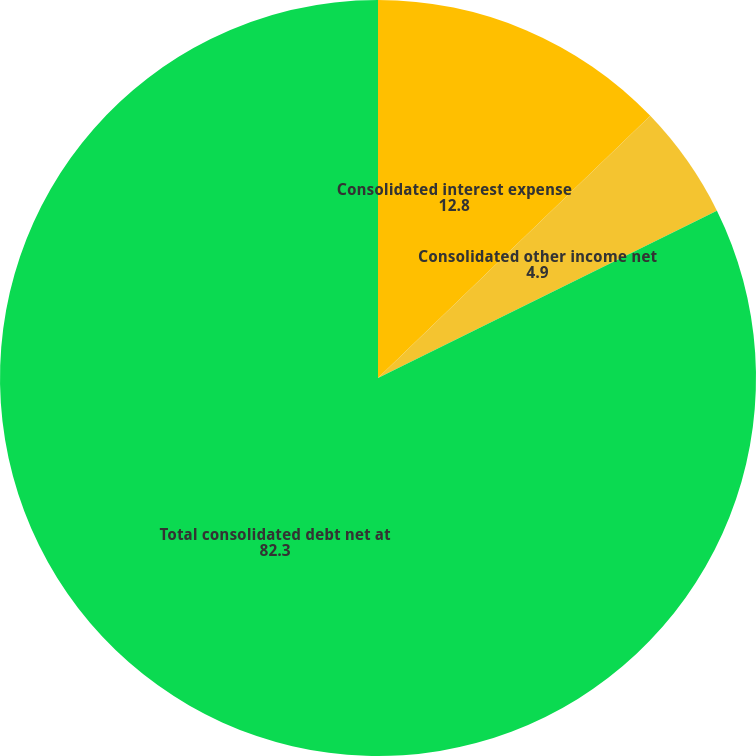Convert chart to OTSL. <chart><loc_0><loc_0><loc_500><loc_500><pie_chart><fcel>Consolidated interest expense<fcel>Consolidated other income net<fcel>Total consolidated debt net at<nl><fcel>12.8%<fcel>4.9%<fcel>82.3%<nl></chart> 